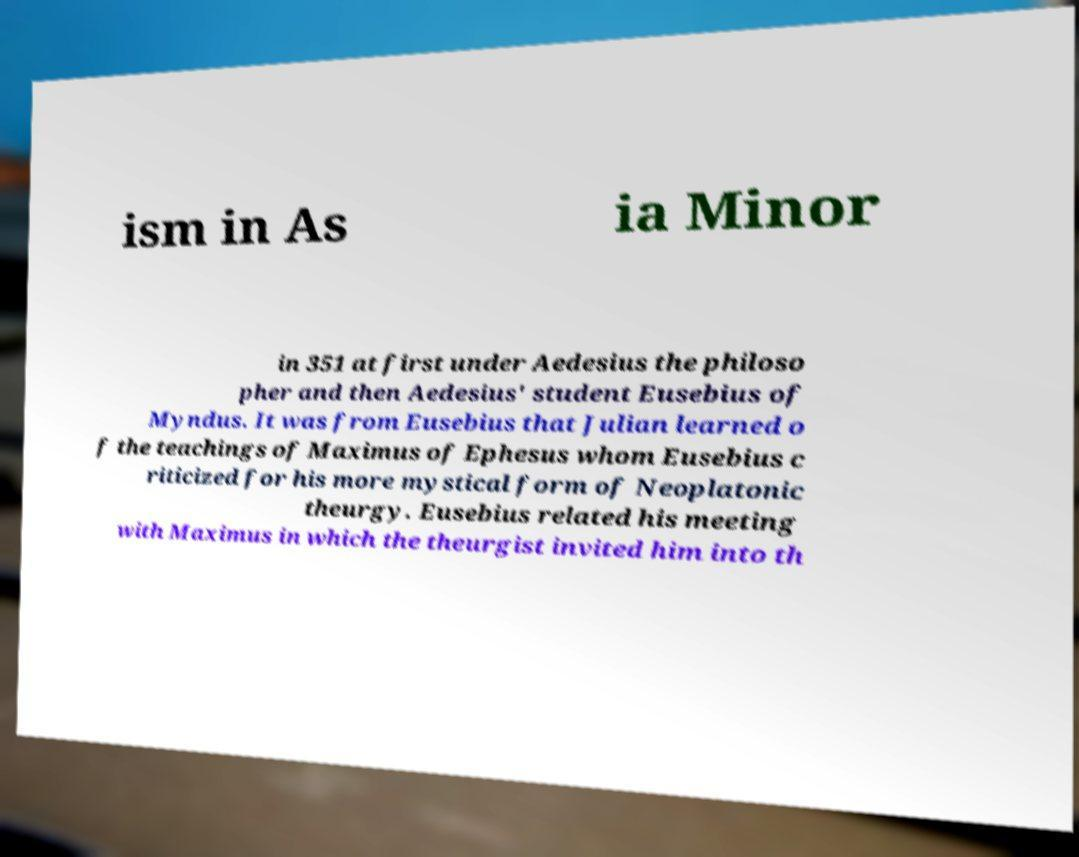I need the written content from this picture converted into text. Can you do that? ism in As ia Minor in 351 at first under Aedesius the philoso pher and then Aedesius' student Eusebius of Myndus. It was from Eusebius that Julian learned o f the teachings of Maximus of Ephesus whom Eusebius c riticized for his more mystical form of Neoplatonic theurgy. Eusebius related his meeting with Maximus in which the theurgist invited him into th 